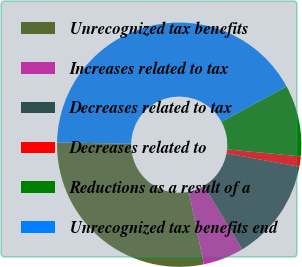Convert chart to OTSL. <chart><loc_0><loc_0><loc_500><loc_500><pie_chart><fcel>Unrecognized tax benefits<fcel>Increases related to tax<fcel>Decreases related to tax<fcel>Decreases related to<fcel>Reductions as a result of a<fcel>Unrecognized tax benefits end<nl><fcel>28.53%<fcel>5.39%<fcel>13.48%<fcel>1.35%<fcel>9.44%<fcel>41.8%<nl></chart> 